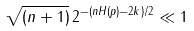Convert formula to latex. <formula><loc_0><loc_0><loc_500><loc_500>\sqrt { ( n + 1 ) } \, 2 ^ { - ( n H ( p ) - 2 k ) / 2 } \ll 1</formula> 